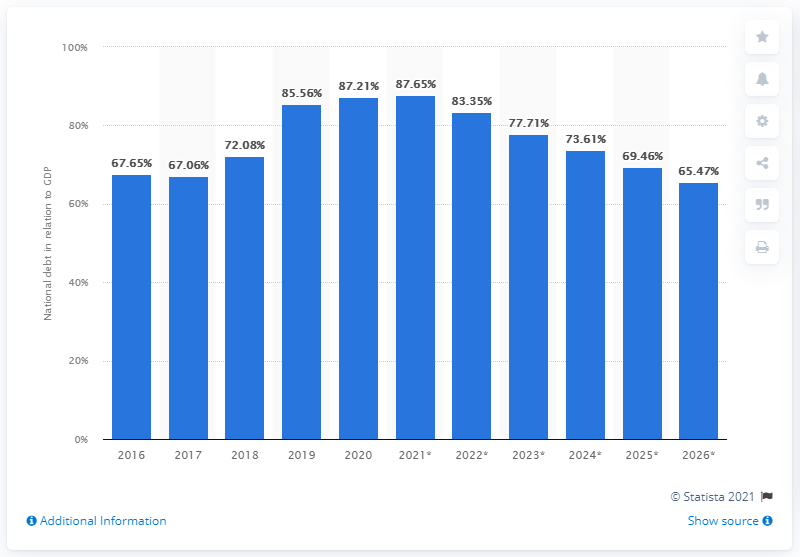List a handful of essential elements in this visual. In 2020, Pakistan's national debt represented approximately 87.65% of Pakistan's Gross Domestic Product (GDP). 